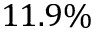<formula> <loc_0><loc_0><loc_500><loc_500>1 1 . 9 \%</formula> 